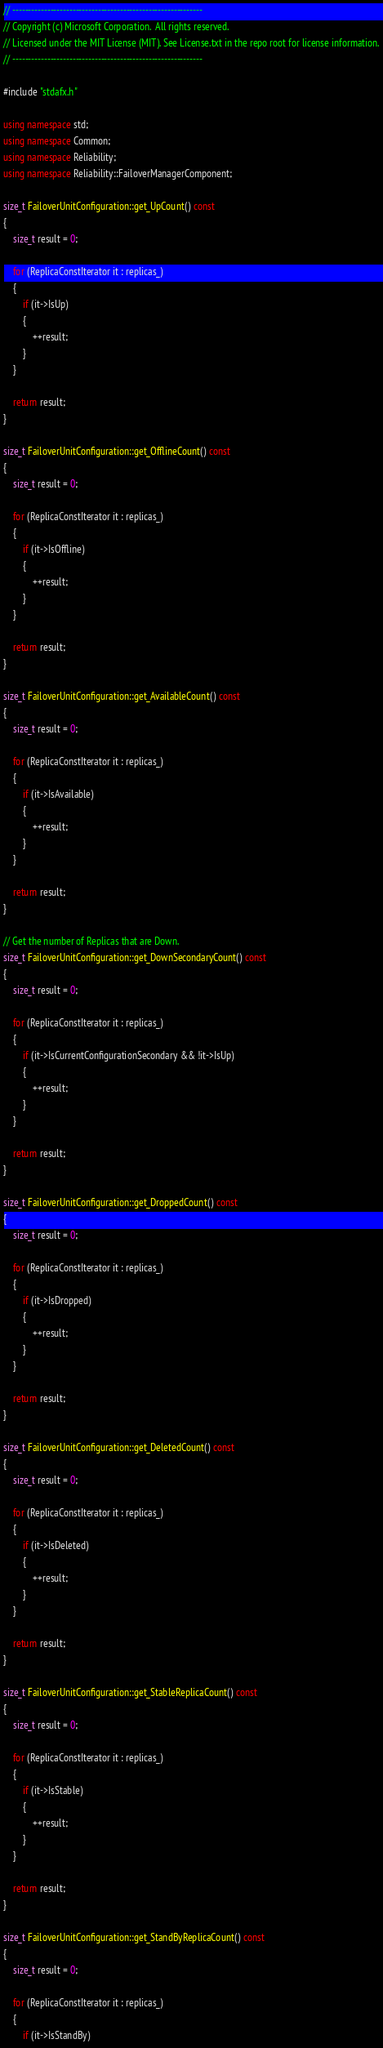Convert code to text. <code><loc_0><loc_0><loc_500><loc_500><_C++_>// ------------------------------------------------------------
// Copyright (c) Microsoft Corporation.  All rights reserved.
// Licensed under the MIT License (MIT). See License.txt in the repo root for license information.
// ------------------------------------------------------------

#include "stdafx.h"

using namespace std;
using namespace Common;
using namespace Reliability;
using namespace Reliability::FailoverManagerComponent;

size_t FailoverUnitConfiguration::get_UpCount() const
{
    size_t result = 0;

    for (ReplicaConstIterator it : replicas_)
    {
        if (it->IsUp)
        {
            ++result;
        }
    }

    return result;
}

size_t FailoverUnitConfiguration::get_OfflineCount() const
{
    size_t result = 0;

    for (ReplicaConstIterator it : replicas_)
    {
        if (it->IsOffline)
        {
            ++result;
        }
    }

    return result;
}

size_t FailoverUnitConfiguration::get_AvailableCount() const
{
    size_t result = 0;

    for (ReplicaConstIterator it : replicas_)
    {
        if (it->IsAvailable)
        {
            ++result;
        }
    }

    return result;
}

// Get the number of Replicas that are Down.
size_t FailoverUnitConfiguration::get_DownSecondaryCount() const
{
    size_t result = 0;

    for (ReplicaConstIterator it : replicas_)
    {
        if (it->IsCurrentConfigurationSecondary && !it->IsUp)
        {
            ++result;
        }
    }

    return result;
}

size_t FailoverUnitConfiguration::get_DroppedCount() const
{
    size_t result = 0;

    for (ReplicaConstIterator it : replicas_)
    {
        if (it->IsDropped)
        {
            ++result;
        }
    }

    return result;
}

size_t FailoverUnitConfiguration::get_DeletedCount() const
{
    size_t result = 0;

    for (ReplicaConstIterator it : replicas_)
    {
        if (it->IsDeleted)
        {
            ++result;
        }
    }

    return result;
}

size_t FailoverUnitConfiguration::get_StableReplicaCount() const
{
    size_t result = 0;

    for (ReplicaConstIterator it : replicas_)
    {
        if (it->IsStable)
        {
            ++result;
        }
    }

    return result;
}

size_t FailoverUnitConfiguration::get_StandByReplicaCount() const
{
	size_t result = 0;

	for (ReplicaConstIterator it : replicas_)
	{
		if (it->IsStandBy)</code> 